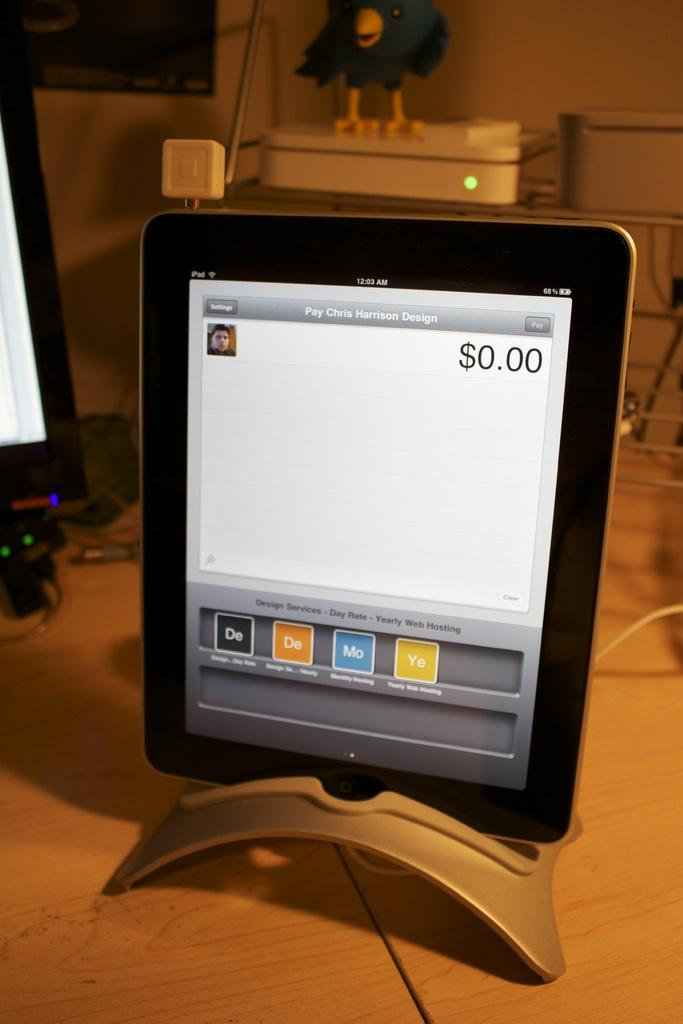<image>
Provide a brief description of the given image. A tablet screen displays a program opened that is going to "pay Chris Harrison Design." 